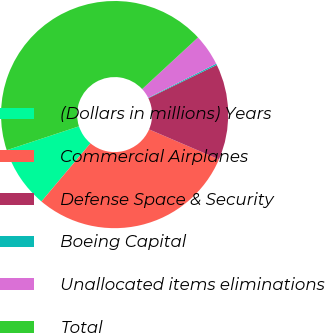Convert chart. <chart><loc_0><loc_0><loc_500><loc_500><pie_chart><fcel>(Dollars in millions) Years<fcel>Commercial Airplanes<fcel>Defense Space & Security<fcel>Boeing Capital<fcel>Unallocated items eliminations<fcel>Total<nl><fcel>8.79%<fcel>29.68%<fcel>13.66%<fcel>0.19%<fcel>4.49%<fcel>43.2%<nl></chart> 